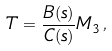Convert formula to latex. <formula><loc_0><loc_0><loc_500><loc_500>T = \frac { B ( s ) } { C ( s ) } M _ { 3 } \, ,</formula> 